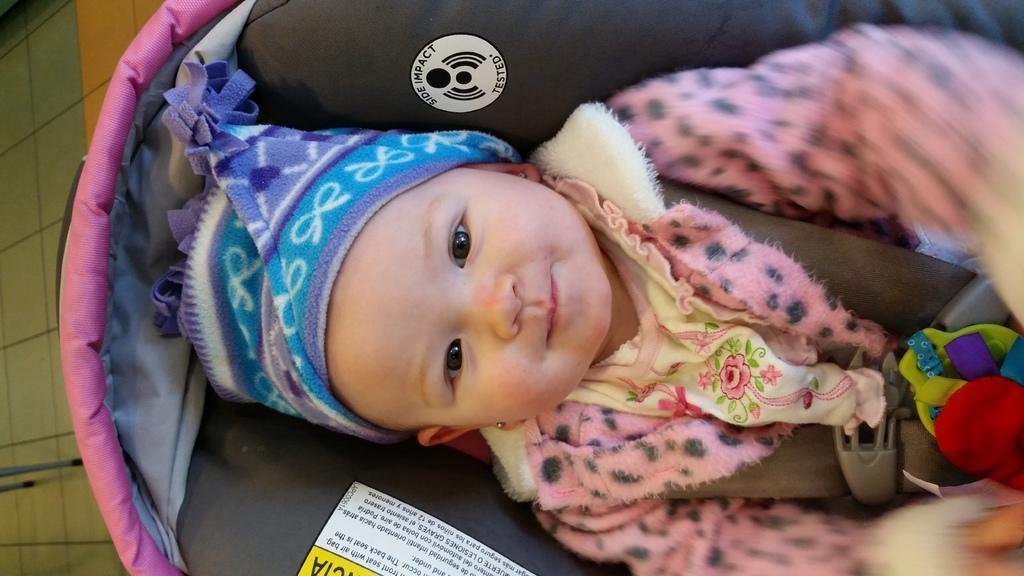What is the baby doing in the image? The baby is lying in a baby carrier in the image. What can be seen on the left side of the image? There are poles on the floor on the left side of the image. What type of machine is being used to weigh the baby in the image? There is no machine present in the image, and the baby is not being weighed. 